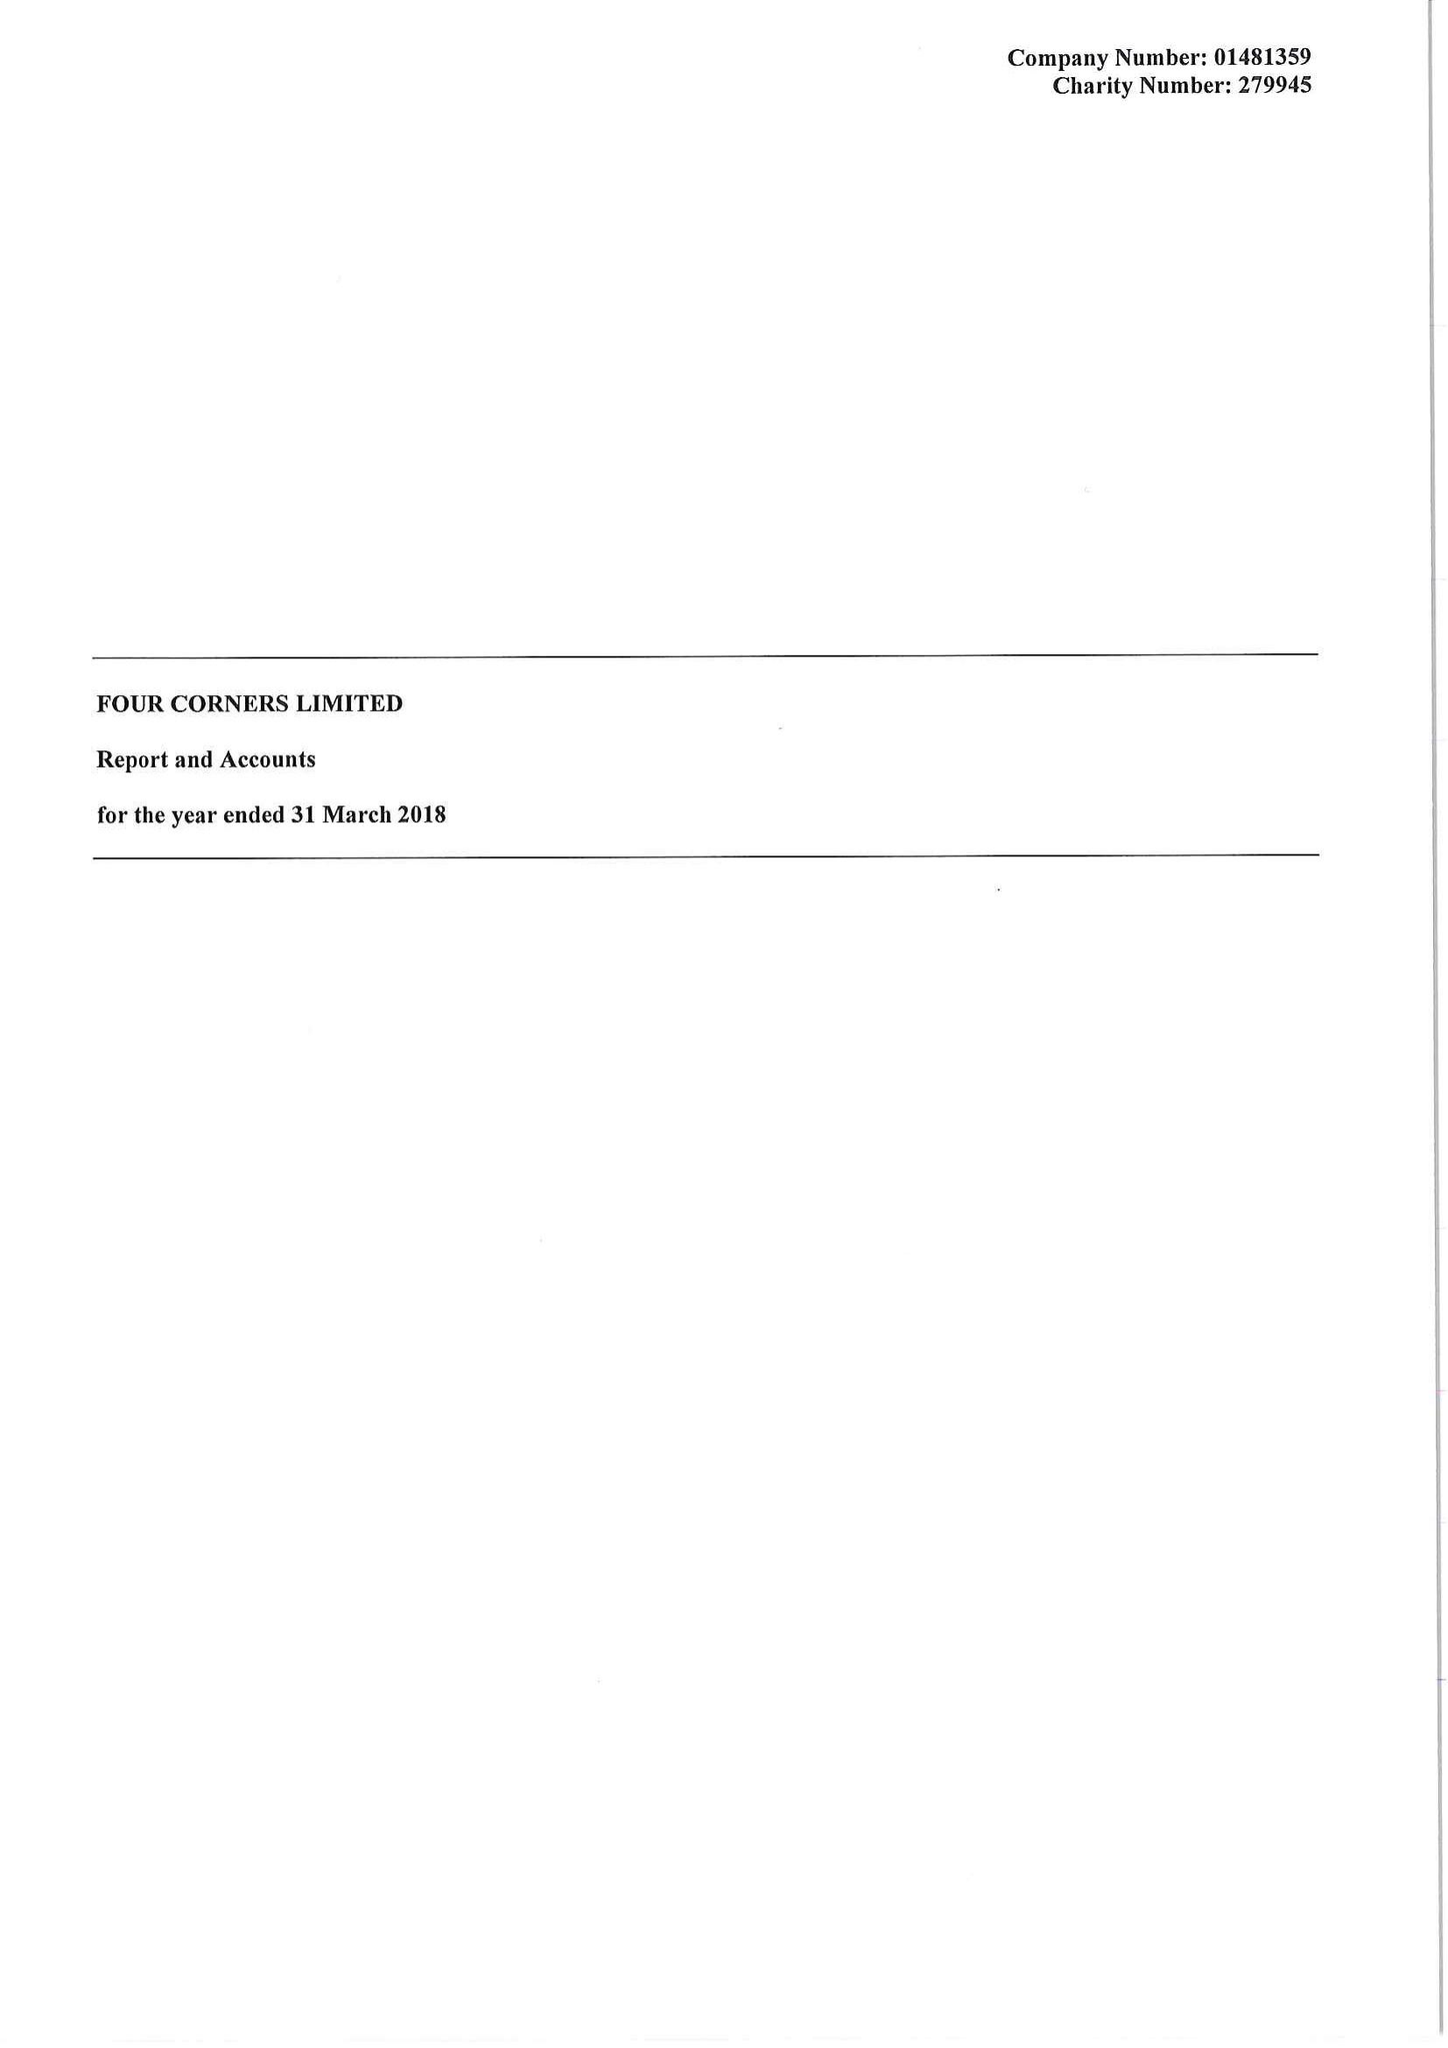What is the value for the charity_name?
Answer the question using a single word or phrase. Four Corners Ltd. 